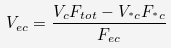Convert formula to latex. <formula><loc_0><loc_0><loc_500><loc_500>V _ { e c } = \frac { V _ { c } F _ { t o t } - V _ { ^ { * } c } F _ { ^ { * } c } } { F _ { e c } }</formula> 